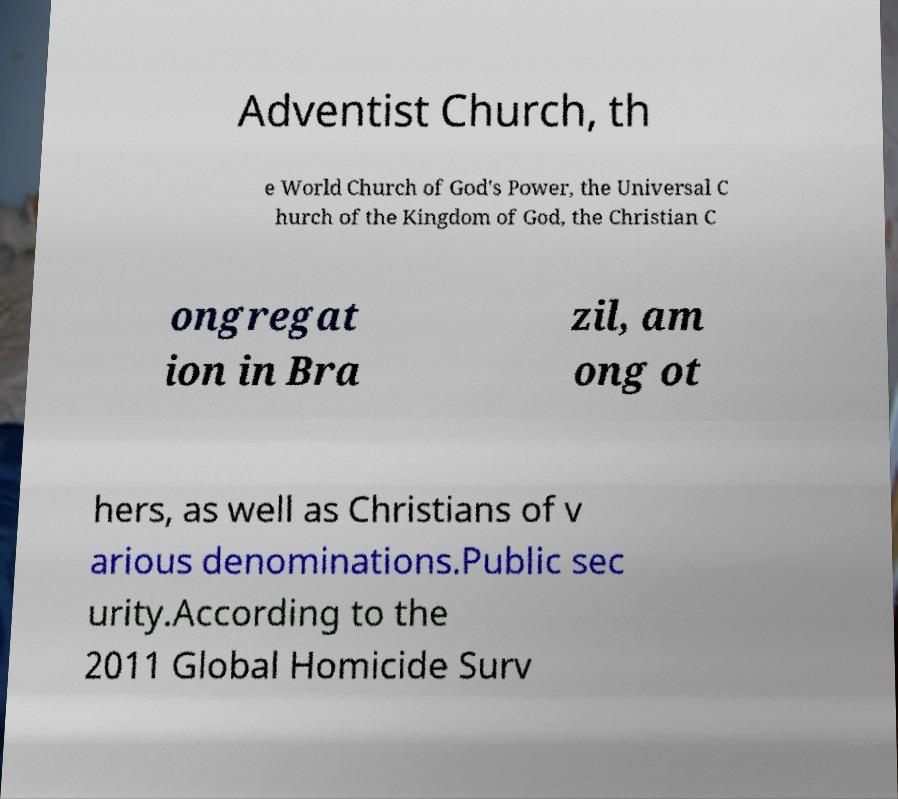I need the written content from this picture converted into text. Can you do that? Adventist Church, th e World Church of God's Power, the Universal C hurch of the Kingdom of God, the Christian C ongregat ion in Bra zil, am ong ot hers, as well as Christians of v arious denominations.Public sec urity.According to the 2011 Global Homicide Surv 